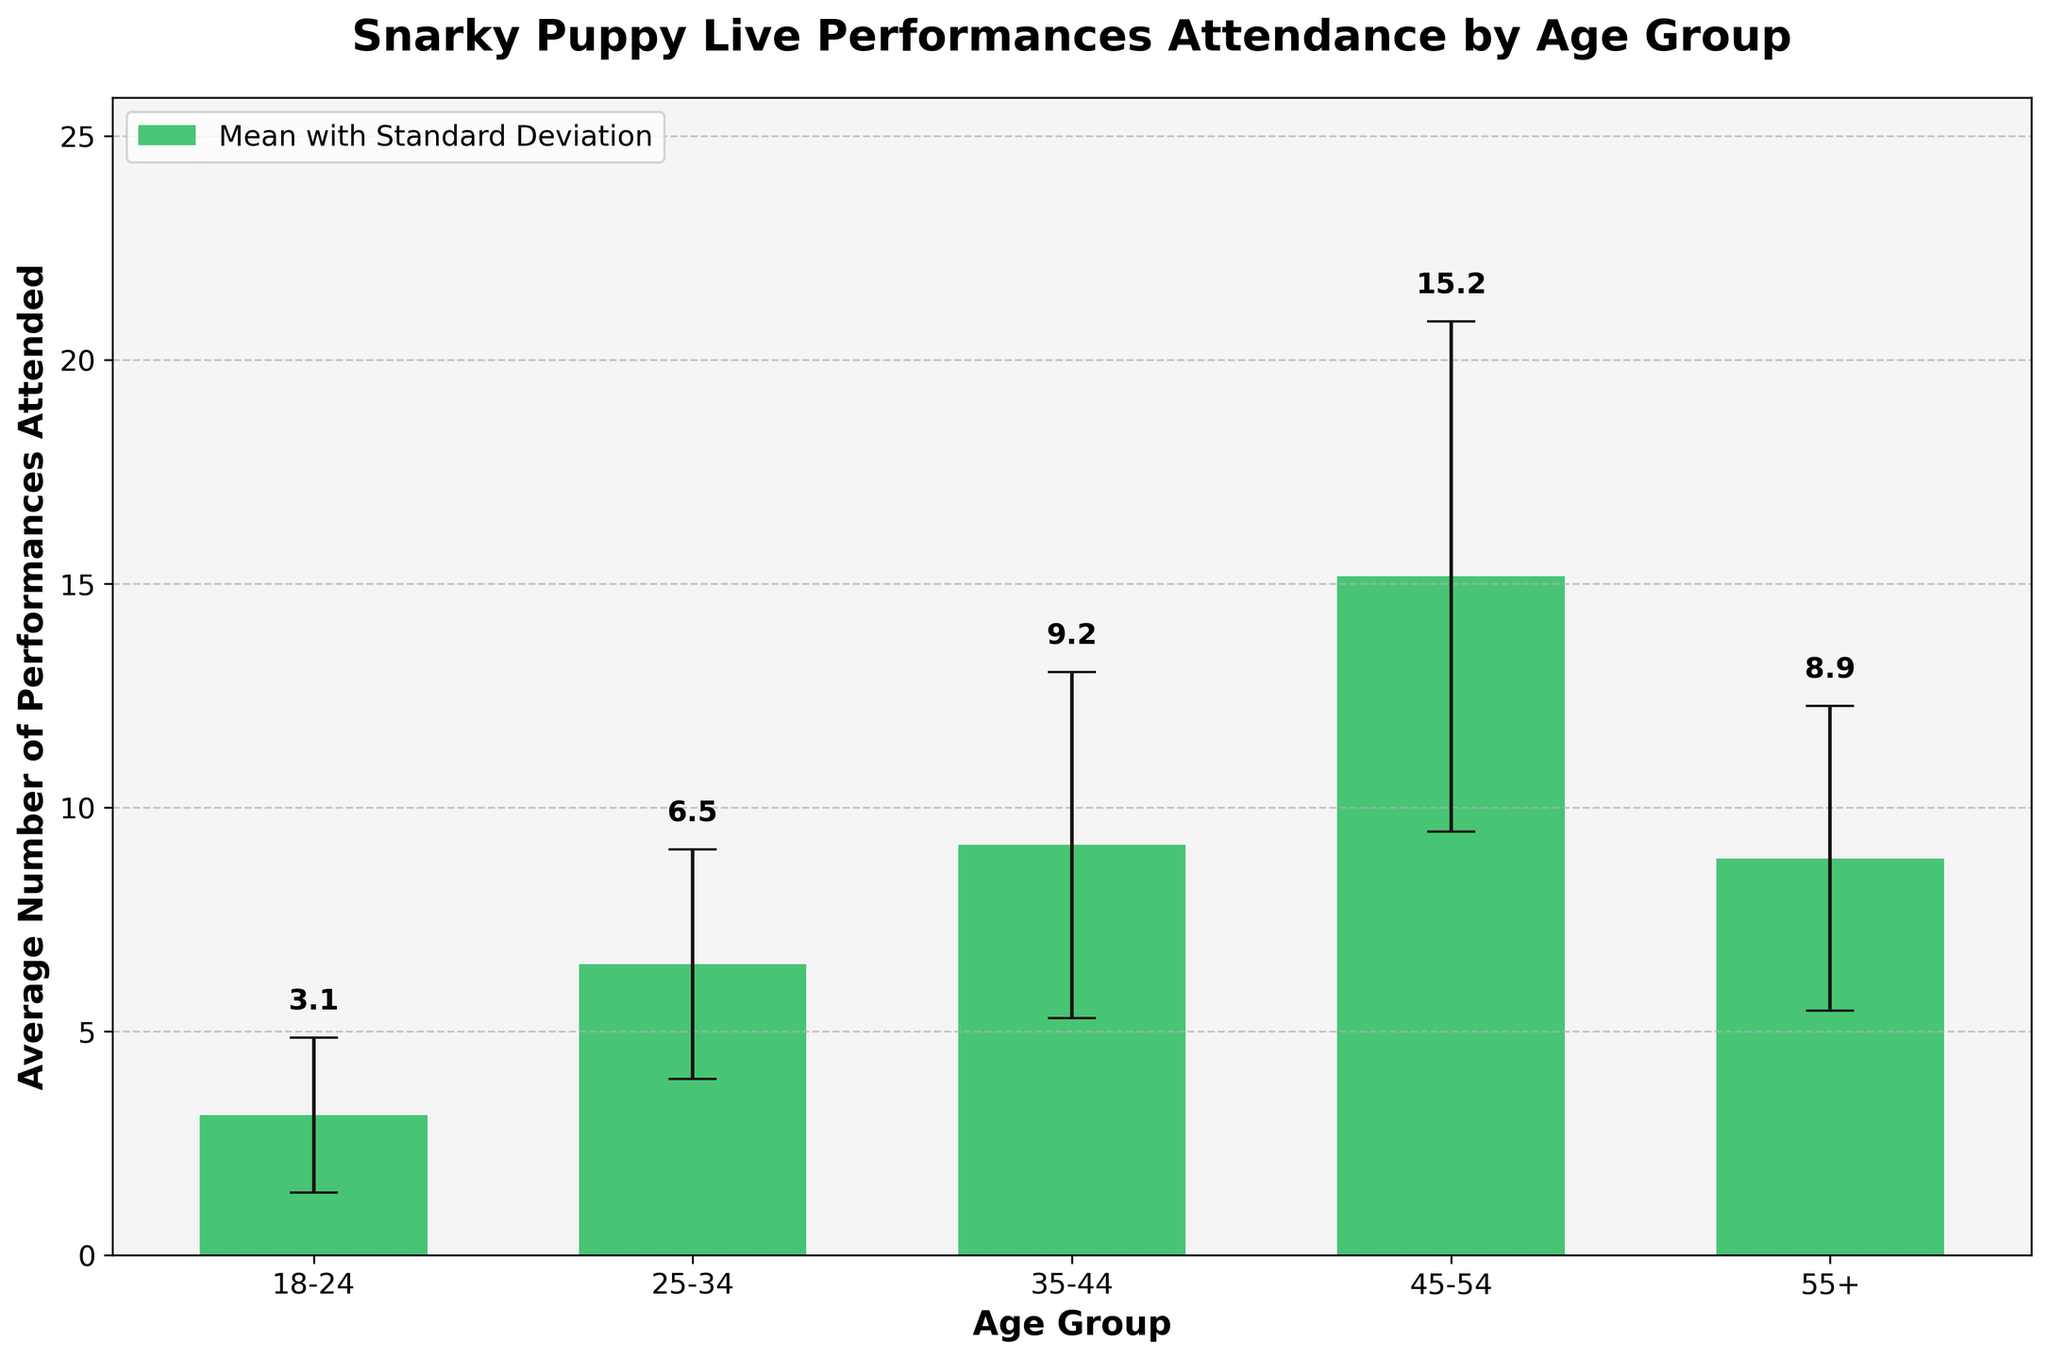What is the title of the plot? The title is located at the top of the plot and typically describes the main focus.
Answer: Snarky Puppy Live Performances Attendance by Age Group What age group has the highest mean number of performances attended? By examining the height of the bars, the tallest bar indicates the highest mean for an age group.
Answer: 45-54 Which age group has the largest standard deviation for the number of performances attended? The largest error bar indicates the age group with the largest standard deviation.
Answer: 45-54 What is the average number of performances attended by the 25-34 age group? By looking at the bar height for the 25-34 age group and the labeled value, we can find the mean number.
Answer: 6.5 How does the mean number of performances attended by the 35-44 age group compare to the 55+ age group? Comparing the heights of the bars for these age groups, we see which one is higher.
Answer: The 35-44 age group has a higher mean What is the range of the average number of performances attended by fans aged 35-44? Finding the range involves the highest and lowest values within the age group, considering the means and standard deviations. The maximum range is mean + std and the minimum is mean - std.
Answer: 5.6 to 15.6 Which age group shows the most variability in the number of performances attended? The age group with the largest error bars indicates the most variability.
Answer: 45-54 How many age groups are represented in the plot? Count the different labeled age groups on the x-axis.
Answer: 5 Does the mean number of performances attended increase or decrease with age? By examining the trends in bar heights from youngest to oldest groups, it shows the general direction of change.
Answer: Increase What is the total mean number of performances attended by all age groups combined? Sum the mean values of each age group: 3.1 + 6.5 + 9.2 + 15.2 + 8.2
Answer: 42.2 